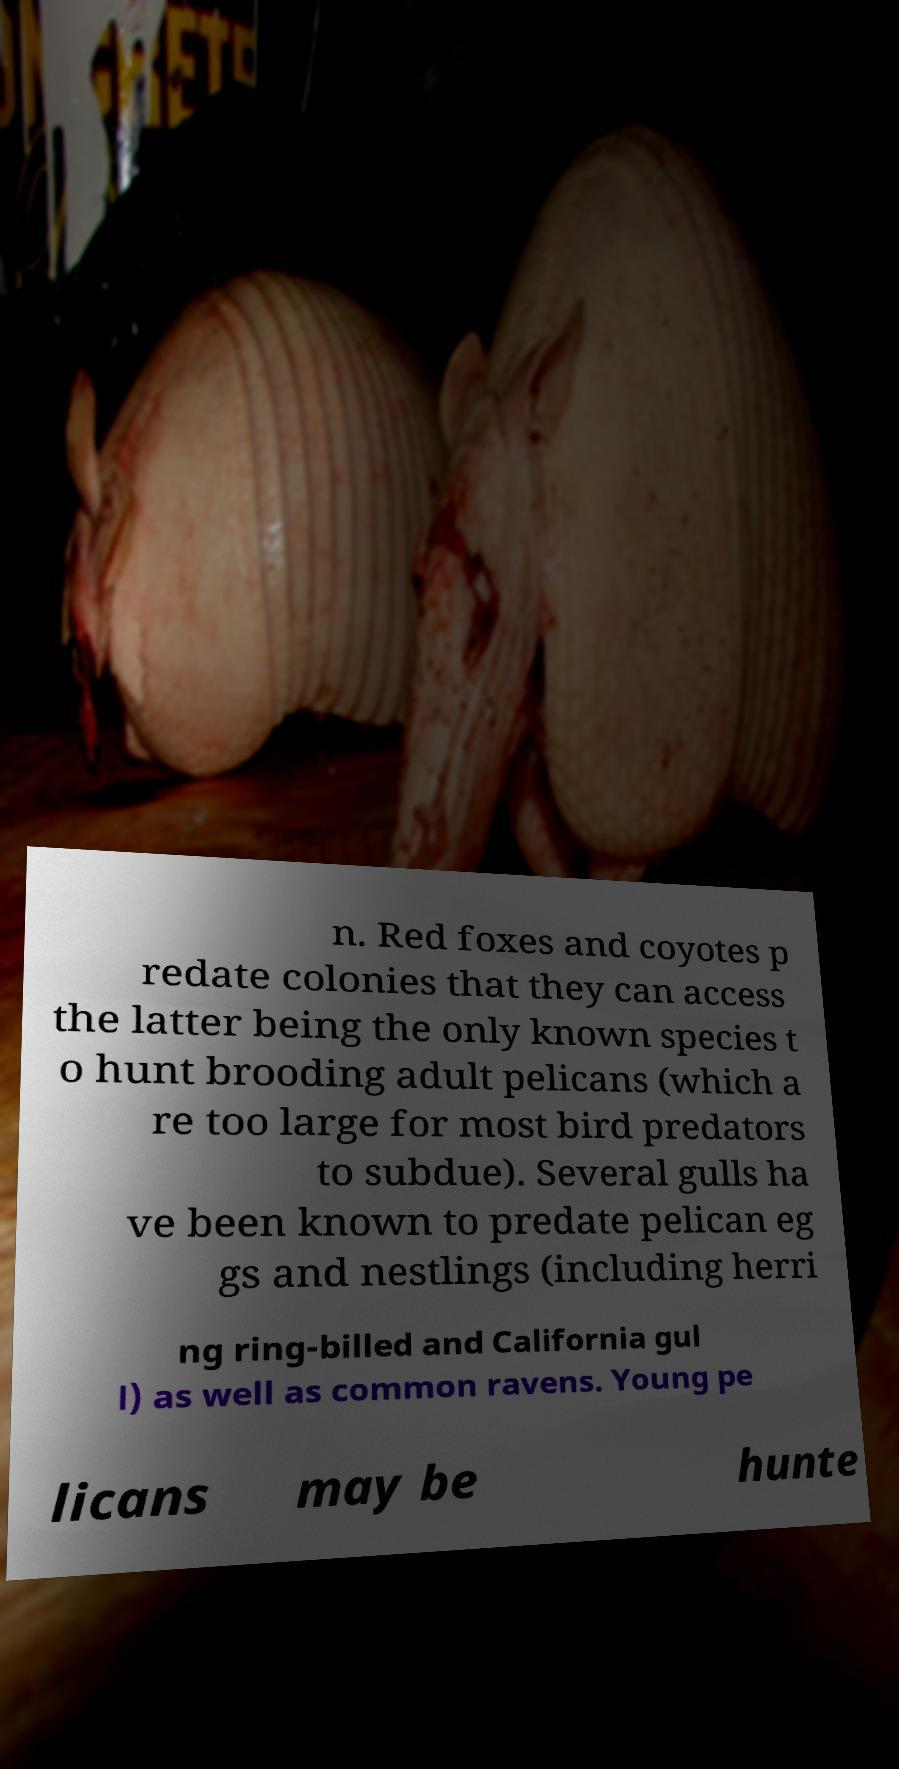I need the written content from this picture converted into text. Can you do that? n. Red foxes and coyotes p redate colonies that they can access the latter being the only known species t o hunt brooding adult pelicans (which a re too large for most bird predators to subdue). Several gulls ha ve been known to predate pelican eg gs and nestlings (including herri ng ring-billed and California gul l) as well as common ravens. Young pe licans may be hunte 